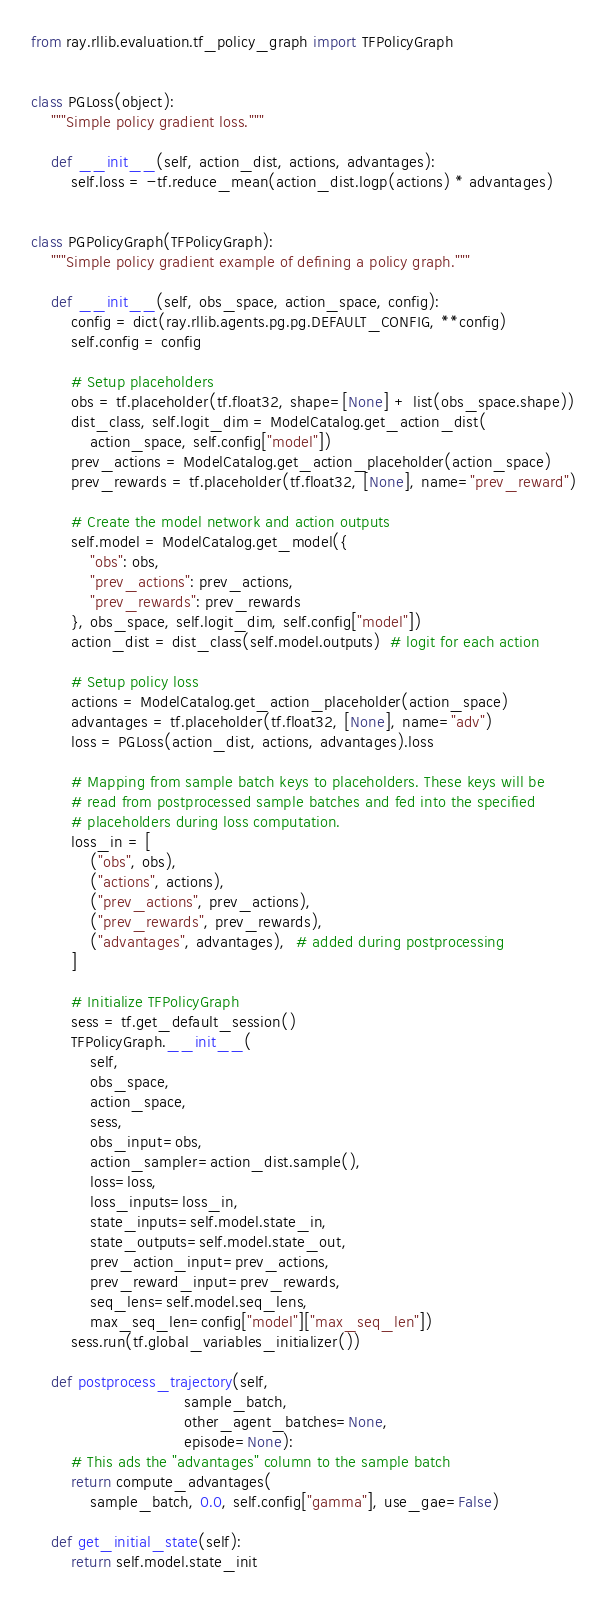<code> <loc_0><loc_0><loc_500><loc_500><_Python_>from ray.rllib.evaluation.tf_policy_graph import TFPolicyGraph


class PGLoss(object):
    """Simple policy gradient loss."""

    def __init__(self, action_dist, actions, advantages):
        self.loss = -tf.reduce_mean(action_dist.logp(actions) * advantages)


class PGPolicyGraph(TFPolicyGraph):
    """Simple policy gradient example of defining a policy graph."""

    def __init__(self, obs_space, action_space, config):
        config = dict(ray.rllib.agents.pg.pg.DEFAULT_CONFIG, **config)
        self.config = config

        # Setup placeholders
        obs = tf.placeholder(tf.float32, shape=[None] + list(obs_space.shape))
        dist_class, self.logit_dim = ModelCatalog.get_action_dist(
            action_space, self.config["model"])
        prev_actions = ModelCatalog.get_action_placeholder(action_space)
        prev_rewards = tf.placeholder(tf.float32, [None], name="prev_reward")

        # Create the model network and action outputs
        self.model = ModelCatalog.get_model({
            "obs": obs,
            "prev_actions": prev_actions,
            "prev_rewards": prev_rewards
        }, obs_space, self.logit_dim, self.config["model"])
        action_dist = dist_class(self.model.outputs)  # logit for each action

        # Setup policy loss
        actions = ModelCatalog.get_action_placeholder(action_space)
        advantages = tf.placeholder(tf.float32, [None], name="adv")
        loss = PGLoss(action_dist, actions, advantages).loss

        # Mapping from sample batch keys to placeholders. These keys will be
        # read from postprocessed sample batches and fed into the specified
        # placeholders during loss computation.
        loss_in = [
            ("obs", obs),
            ("actions", actions),
            ("prev_actions", prev_actions),
            ("prev_rewards", prev_rewards),
            ("advantages", advantages),  # added during postprocessing
        ]

        # Initialize TFPolicyGraph
        sess = tf.get_default_session()
        TFPolicyGraph.__init__(
            self,
            obs_space,
            action_space,
            sess,
            obs_input=obs,
            action_sampler=action_dist.sample(),
            loss=loss,
            loss_inputs=loss_in,
            state_inputs=self.model.state_in,
            state_outputs=self.model.state_out,
            prev_action_input=prev_actions,
            prev_reward_input=prev_rewards,
            seq_lens=self.model.seq_lens,
            max_seq_len=config["model"]["max_seq_len"])
        sess.run(tf.global_variables_initializer())

    def postprocess_trajectory(self,
                               sample_batch,
                               other_agent_batches=None,
                               episode=None):
        # This ads the "advantages" column to the sample batch
        return compute_advantages(
            sample_batch, 0.0, self.config["gamma"], use_gae=False)

    def get_initial_state(self):
        return self.model.state_init
</code> 